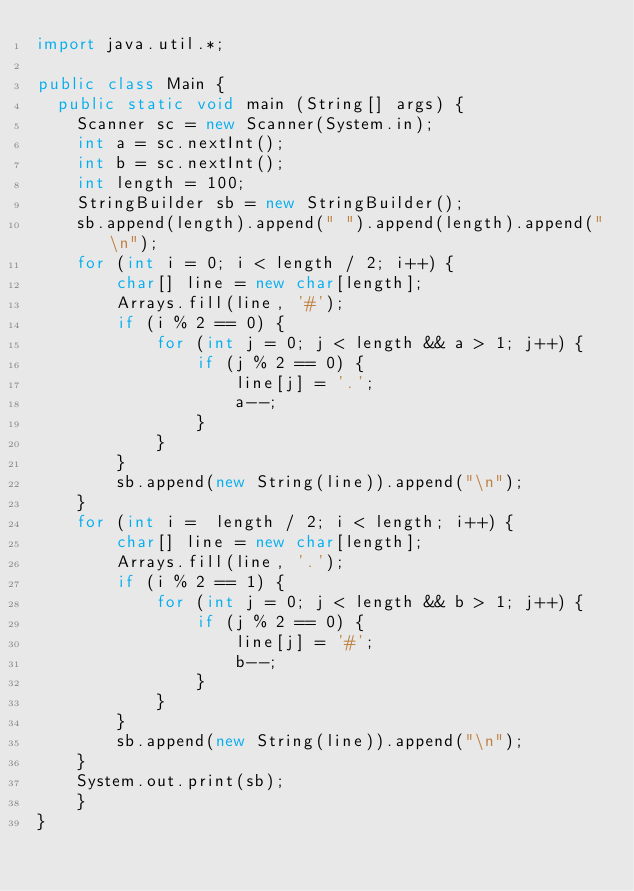<code> <loc_0><loc_0><loc_500><loc_500><_Java_>import java.util.*;

public class Main {
	public static void main (String[] args) {
		Scanner sc = new Scanner(System.in);
		int a = sc.nextInt();
		int b = sc.nextInt();
		int length = 100;
		StringBuilder sb = new StringBuilder();
		sb.append(length).append(" ").append(length).append("\n");
		for (int i = 0; i < length / 2; i++) {
		    char[] line = new char[length];
		    Arrays.fill(line, '#');
		    if (i % 2 == 0) {
		        for (int j = 0; j < length && a > 1; j++) {
		            if (j % 2 == 0) {
		                line[j] = '.';
    		            a--;
		            }
		        }
		    }
		    sb.append(new String(line)).append("\n");
		}
		for (int i =  length / 2; i < length; i++) {
		    char[] line = new char[length];
		    Arrays.fill(line, '.');
		    if (i % 2 == 1) {
		        for (int j = 0; j < length && b > 1; j++) {
		            if (j % 2 == 0) {
		                line[j] = '#';
    		            b--;
		            }
		        }
		    }
		    sb.append(new String(line)).append("\n");
		}
		System.out.print(sb);
    }
}

</code> 